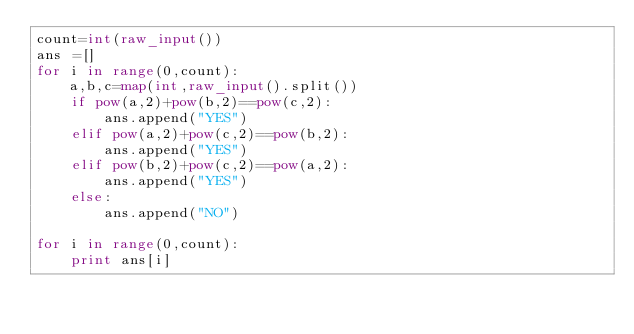Convert code to text. <code><loc_0><loc_0><loc_500><loc_500><_Python_>count=int(raw_input())
ans =[]
for i in range(0,count):
    a,b,c=map(int,raw_input().split())
    if pow(a,2)+pow(b,2)==pow(c,2):
        ans.append("YES")
    elif pow(a,2)+pow(c,2)==pow(b,2):
        ans.append("YES")
    elif pow(b,2)+pow(c,2)==pow(a,2):
        ans.append("YES")
    else:
        ans.append("NO")

for i in range(0,count):
    print ans[i]</code> 